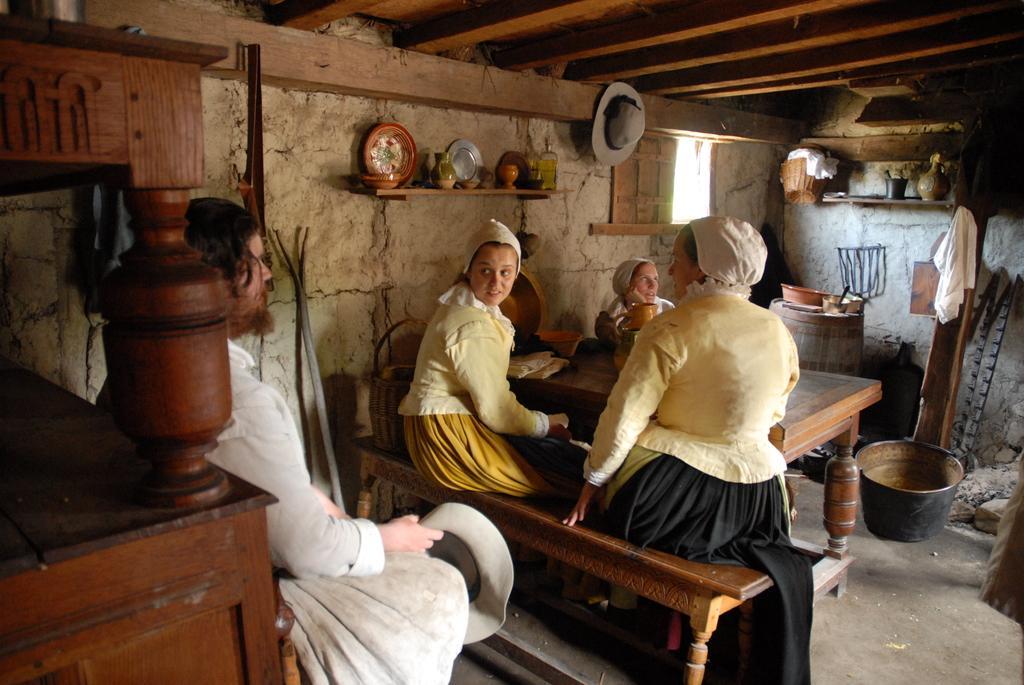Describe this image in one or two sentences. In this picture I can see there is a person sitting at the left side and there are few women sitting on the wooden bench and there is a table in front of them. There is a wooden object at left side and there are few utensils, buckets and clothes placed on the right side. There is a window and the roof has few wooden planks. 